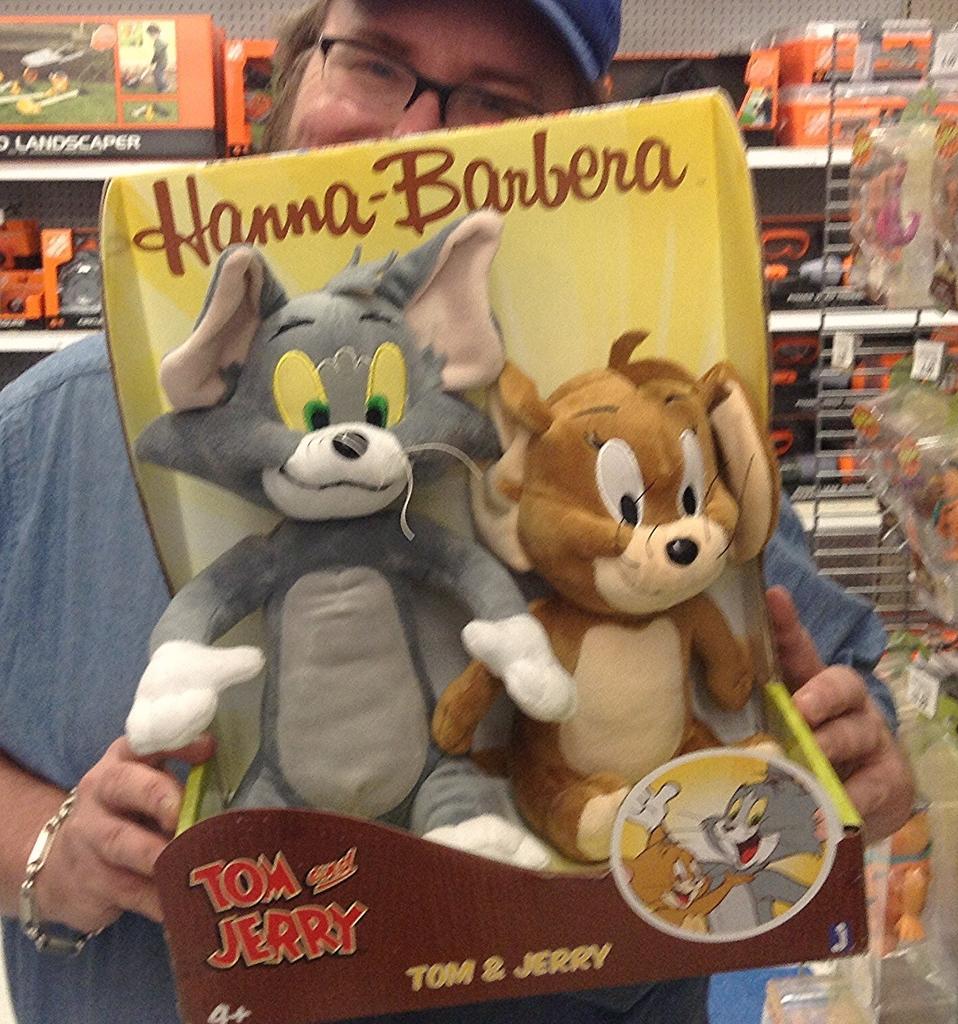How would you summarize this image in a sentence or two? In this image there is a person holding toys in his hand. In the background there are so many toys arranged in a rack. 